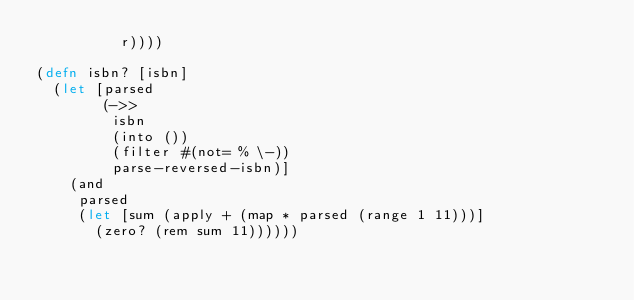Convert code to text. <code><loc_0><loc_0><loc_500><loc_500><_Clojure_>          r))))

(defn isbn? [isbn]
  (let [parsed
        (->>
         isbn
         (into ())
         (filter #(not= % \-))
         parse-reversed-isbn)]
    (and
     parsed
     (let [sum (apply + (map * parsed (range 1 11)))]
       (zero? (rem sum 11))))))
</code> 